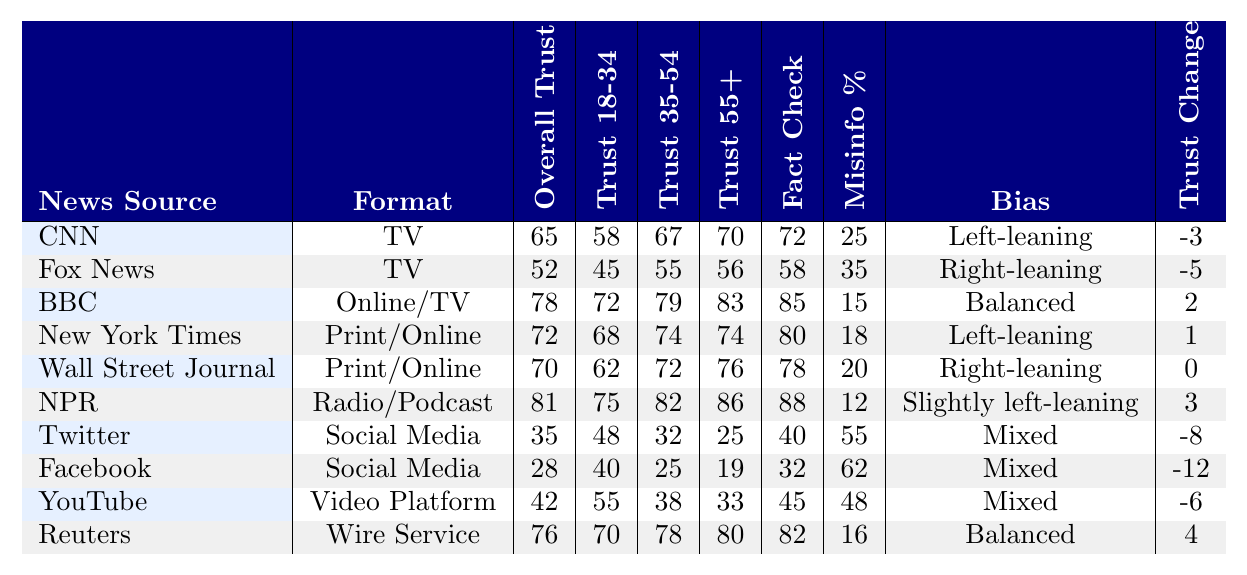What is the overall trust score for CNN? The overall trust score for CNN is listed directly in the table under the "Overall Trust" column for the "CNN" row, which shows a value of 65.
Answer: 65 Which news source has the highest fact-checking score? By examining the "Fact Check" column, NPR shows the highest score at 88, higher than any other source listed.
Answer: NPR What percentage of misinformation is reported for Facebook? The "Misinfo %" column shows the percentage of misinformation reported for Facebook as 62, directly listed in the corresponding row.
Answer: 62 What is the average overall trust score for news sources perceived as “Balanced”? The overall trust scores for sources perceived as "Balanced" (BBC and Reuters) are 78 and 76 respectively. The average is (78 + 76) / 2 = 77.
Answer: 77 Is trust in Twitter among the age group 55 and over higher than for Facebook? In the "Trust 55+" column, Twitter has a trust score of 25, while Facebook shows a score of 19. Since 25 is greater than 19, trust in Twitter is indeed higher.
Answer: Yes Which news source experienced the largest trust decline over the last year? The "Trust Change" column shows that Facebook had the largest decline of -12, which is the lowest value in that column.
Answer: Facebook What is the difference in overall trust scores between NPR and Fox News? NPR has an overall trust score of 81 while Fox News has a score of 52. The difference is calculated as 81 - 52 = 29.
Answer: 29 Among the news sources, which one has the highest trust score among people aged 18 to 34? Reviewing the "Trust 18-34" column, NPR shows the highest score of 75, which is greater than the scores of all other sources for this age group.
Answer: NPR What is the trust score change for the BBC over the last year? The "Trust Change" column indicates that the BBC's trust score changed by +2 over the last year, suggesting a positive trend.
Answer: 2 Is the overall trust score for YouTube higher than that for Twitter? Looking at the "Overall Trust" column, YouTube has a score of 42, while Twitter has a score of 35. Since 42 is higher than 35, YouTube's score is indeed greater.
Answer: Yes 